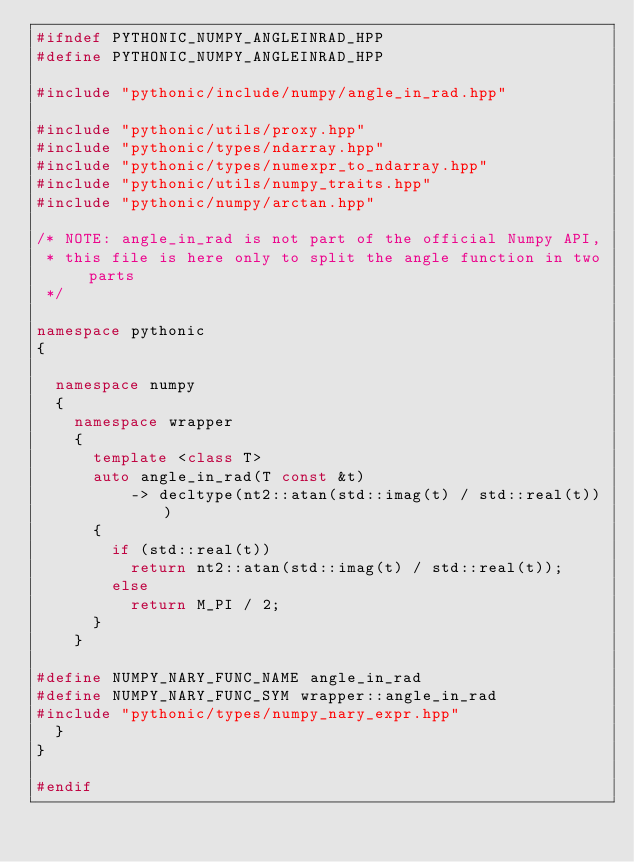<code> <loc_0><loc_0><loc_500><loc_500><_C++_>#ifndef PYTHONIC_NUMPY_ANGLEINRAD_HPP
#define PYTHONIC_NUMPY_ANGLEINRAD_HPP

#include "pythonic/include/numpy/angle_in_rad.hpp"

#include "pythonic/utils/proxy.hpp"
#include "pythonic/types/ndarray.hpp"
#include "pythonic/types/numexpr_to_ndarray.hpp"
#include "pythonic/utils/numpy_traits.hpp"
#include "pythonic/numpy/arctan.hpp"

/* NOTE: angle_in_rad is not part of the official Numpy API,
 * this file is here only to split the angle function in two parts
 */

namespace pythonic
{

  namespace numpy
  {
    namespace wrapper
    {
      template <class T>
      auto angle_in_rad(T const &t)
          -> decltype(nt2::atan(std::imag(t) / std::real(t)))
      {
        if (std::real(t))
          return nt2::atan(std::imag(t) / std::real(t));
        else
          return M_PI / 2;
      }
    }

#define NUMPY_NARY_FUNC_NAME angle_in_rad
#define NUMPY_NARY_FUNC_SYM wrapper::angle_in_rad
#include "pythonic/types/numpy_nary_expr.hpp"
  }
}

#endif
</code> 